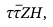Convert formula to latex. <formula><loc_0><loc_0><loc_500><loc_500>\tau \bar { \tau } Z H ,</formula> 